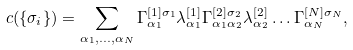<formula> <loc_0><loc_0><loc_500><loc_500>c ( \{ \sigma _ { i } \} ) = \sum _ { \alpha _ { 1 } , \dots , \alpha _ { N } } \Gamma _ { \alpha _ { 1 } } ^ { [ 1 ] \sigma _ { 1 } } \lambda _ { \alpha _ { 1 } } ^ { [ 1 ] } \Gamma _ { \alpha _ { 1 } \alpha _ { 2 } } ^ { [ 2 ] \sigma _ { 2 } } \lambda _ { \alpha _ { 2 } } ^ { [ 2 ] } \dots \Gamma _ { \alpha _ { N } } ^ { [ N ] \sigma _ { N } } ,</formula> 